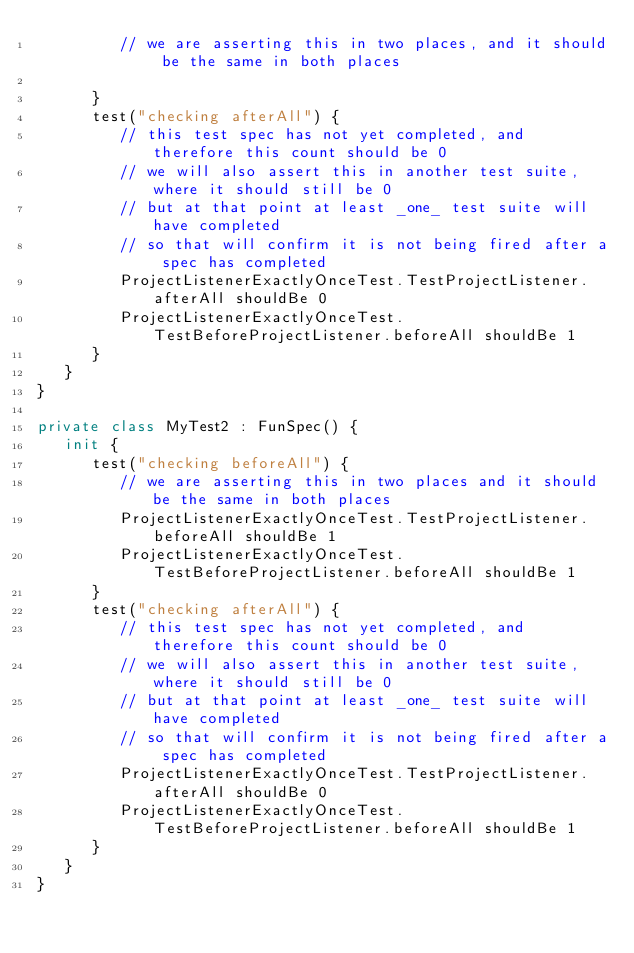<code> <loc_0><loc_0><loc_500><loc_500><_Kotlin_>         // we are asserting this in two places, and it should be the same in both places

      }
      test("checking afterAll") {
         // this test spec has not yet completed, and therefore this count should be 0
         // we will also assert this in another test suite, where it should still be 0
         // but at that point at least _one_ test suite will have completed
         // so that will confirm it is not being fired after a spec has completed
         ProjectListenerExactlyOnceTest.TestProjectListener.afterAll shouldBe 0
         ProjectListenerExactlyOnceTest.TestBeforeProjectListener.beforeAll shouldBe 1
      }
   }
}

private class MyTest2 : FunSpec() {
   init {
      test("checking beforeAll") {
         // we are asserting this in two places and it should be the same in both places
         ProjectListenerExactlyOnceTest.TestProjectListener.beforeAll shouldBe 1
         ProjectListenerExactlyOnceTest.TestBeforeProjectListener.beforeAll shouldBe 1
      }
      test("checking afterAll") {
         // this test spec has not yet completed, and therefore this count should be 0
         // we will also assert this in another test suite, where it should still be 0
         // but at that point at least _one_ test suite will have completed
         // so that will confirm it is not being fired after a spec has completed
         ProjectListenerExactlyOnceTest.TestProjectListener.afterAll shouldBe 0
         ProjectListenerExactlyOnceTest.TestBeforeProjectListener.beforeAll shouldBe 1
      }
   }
}
</code> 